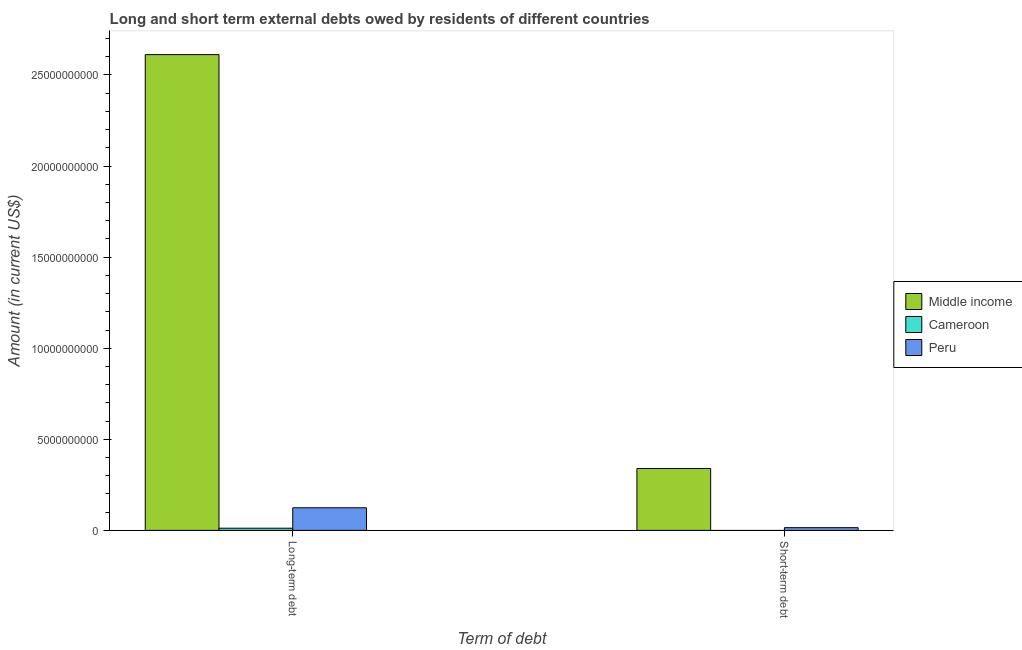How many groups of bars are there?
Keep it short and to the point. 2. Are the number of bars per tick equal to the number of legend labels?
Give a very brief answer. No. What is the label of the 2nd group of bars from the left?
Ensure brevity in your answer.  Short-term debt. What is the long-term debts owed by residents in Cameroon?
Ensure brevity in your answer.  1.19e+08. Across all countries, what is the maximum long-term debts owed by residents?
Provide a short and direct response. 2.61e+1. Across all countries, what is the minimum short-term debts owed by residents?
Make the answer very short. 0. In which country was the long-term debts owed by residents maximum?
Provide a short and direct response. Middle income. What is the total long-term debts owed by residents in the graph?
Offer a very short reply. 2.75e+1. What is the difference between the long-term debts owed by residents in Peru and that in Middle income?
Provide a short and direct response. -2.49e+1. What is the difference between the short-term debts owed by residents in Peru and the long-term debts owed by residents in Cameroon?
Your answer should be very brief. 2.97e+07. What is the average short-term debts owed by residents per country?
Your answer should be very brief. 1.18e+09. What is the difference between the long-term debts owed by residents and short-term debts owed by residents in Middle income?
Your answer should be compact. 2.27e+1. In how many countries, is the short-term debts owed by residents greater than 23000000000 US$?
Offer a very short reply. 0. What is the ratio of the long-term debts owed by residents in Cameroon to that in Peru?
Offer a terse response. 0.1. Is the long-term debts owed by residents in Peru less than that in Middle income?
Provide a short and direct response. Yes. Are all the bars in the graph horizontal?
Provide a short and direct response. No. How many countries are there in the graph?
Ensure brevity in your answer.  3. What is the difference between two consecutive major ticks on the Y-axis?
Your answer should be compact. 5.00e+09. Does the graph contain any zero values?
Keep it short and to the point. Yes. How are the legend labels stacked?
Your answer should be compact. Vertical. What is the title of the graph?
Provide a succinct answer. Long and short term external debts owed by residents of different countries. What is the label or title of the X-axis?
Your answer should be compact. Term of debt. What is the label or title of the Y-axis?
Keep it short and to the point. Amount (in current US$). What is the Amount (in current US$) in Middle income in Long-term debt?
Your answer should be very brief. 2.61e+1. What is the Amount (in current US$) in Cameroon in Long-term debt?
Provide a succinct answer. 1.19e+08. What is the Amount (in current US$) of Peru in Long-term debt?
Keep it short and to the point. 1.24e+09. What is the Amount (in current US$) in Middle income in Short-term debt?
Provide a short and direct response. 3.40e+09. What is the Amount (in current US$) in Cameroon in Short-term debt?
Make the answer very short. 0. What is the Amount (in current US$) of Peru in Short-term debt?
Provide a succinct answer. 1.49e+08. Across all Term of debt, what is the maximum Amount (in current US$) of Middle income?
Provide a short and direct response. 2.61e+1. Across all Term of debt, what is the maximum Amount (in current US$) of Cameroon?
Provide a short and direct response. 1.19e+08. Across all Term of debt, what is the maximum Amount (in current US$) of Peru?
Provide a short and direct response. 1.24e+09. Across all Term of debt, what is the minimum Amount (in current US$) of Middle income?
Keep it short and to the point. 3.40e+09. Across all Term of debt, what is the minimum Amount (in current US$) of Cameroon?
Your answer should be compact. 0. Across all Term of debt, what is the minimum Amount (in current US$) of Peru?
Offer a very short reply. 1.49e+08. What is the total Amount (in current US$) of Middle income in the graph?
Provide a short and direct response. 2.95e+1. What is the total Amount (in current US$) of Cameroon in the graph?
Your answer should be compact. 1.19e+08. What is the total Amount (in current US$) in Peru in the graph?
Give a very brief answer. 1.39e+09. What is the difference between the Amount (in current US$) in Middle income in Long-term debt and that in Short-term debt?
Provide a short and direct response. 2.27e+1. What is the difference between the Amount (in current US$) of Peru in Long-term debt and that in Short-term debt?
Provide a succinct answer. 1.09e+09. What is the difference between the Amount (in current US$) of Middle income in Long-term debt and the Amount (in current US$) of Peru in Short-term debt?
Your answer should be very brief. 2.60e+1. What is the difference between the Amount (in current US$) in Cameroon in Long-term debt and the Amount (in current US$) in Peru in Short-term debt?
Make the answer very short. -2.97e+07. What is the average Amount (in current US$) in Middle income per Term of debt?
Your answer should be compact. 1.48e+1. What is the average Amount (in current US$) of Cameroon per Term of debt?
Your response must be concise. 5.97e+07. What is the average Amount (in current US$) in Peru per Term of debt?
Ensure brevity in your answer.  6.95e+08. What is the difference between the Amount (in current US$) in Middle income and Amount (in current US$) in Cameroon in Long-term debt?
Your response must be concise. 2.60e+1. What is the difference between the Amount (in current US$) of Middle income and Amount (in current US$) of Peru in Long-term debt?
Provide a succinct answer. 2.49e+1. What is the difference between the Amount (in current US$) in Cameroon and Amount (in current US$) in Peru in Long-term debt?
Provide a succinct answer. -1.12e+09. What is the difference between the Amount (in current US$) in Middle income and Amount (in current US$) in Peru in Short-term debt?
Provide a short and direct response. 3.25e+09. What is the ratio of the Amount (in current US$) in Middle income in Long-term debt to that in Short-term debt?
Offer a very short reply. 7.69. What is the ratio of the Amount (in current US$) in Peru in Long-term debt to that in Short-term debt?
Provide a succinct answer. 8.32. What is the difference between the highest and the second highest Amount (in current US$) of Middle income?
Offer a very short reply. 2.27e+1. What is the difference between the highest and the second highest Amount (in current US$) in Peru?
Give a very brief answer. 1.09e+09. What is the difference between the highest and the lowest Amount (in current US$) of Middle income?
Your answer should be very brief. 2.27e+1. What is the difference between the highest and the lowest Amount (in current US$) of Cameroon?
Your answer should be compact. 1.19e+08. What is the difference between the highest and the lowest Amount (in current US$) in Peru?
Keep it short and to the point. 1.09e+09. 